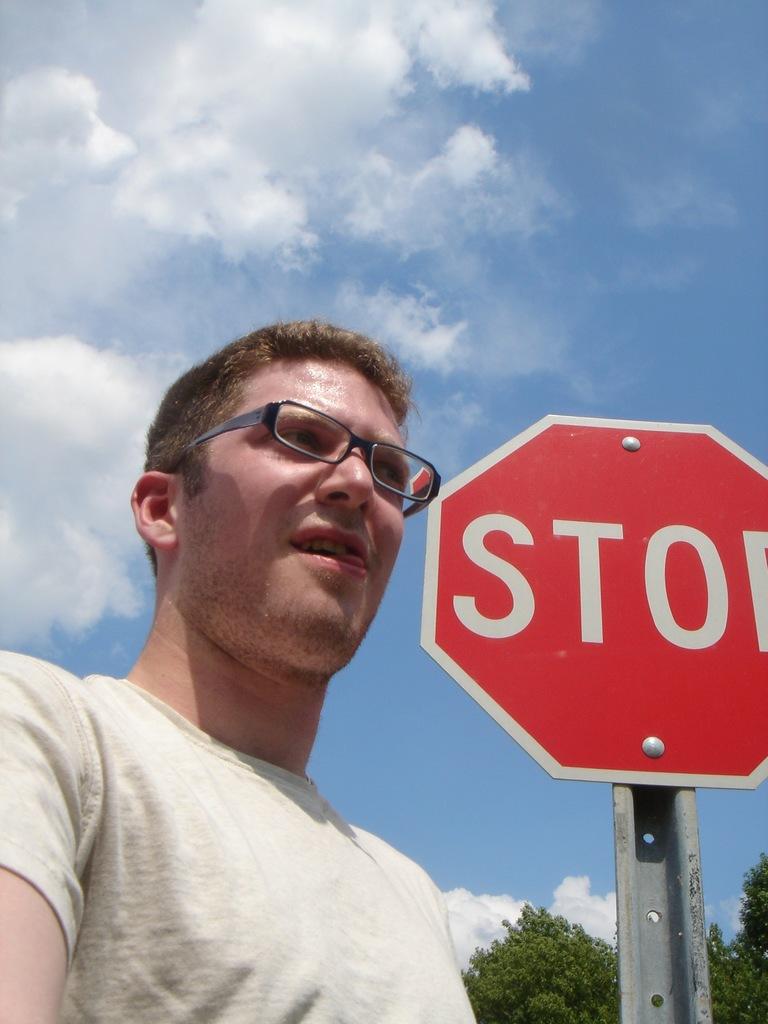What is the sign telling cars to do?
Provide a short and direct response. Stop. What color is his shirt?
Provide a succinct answer. White. 